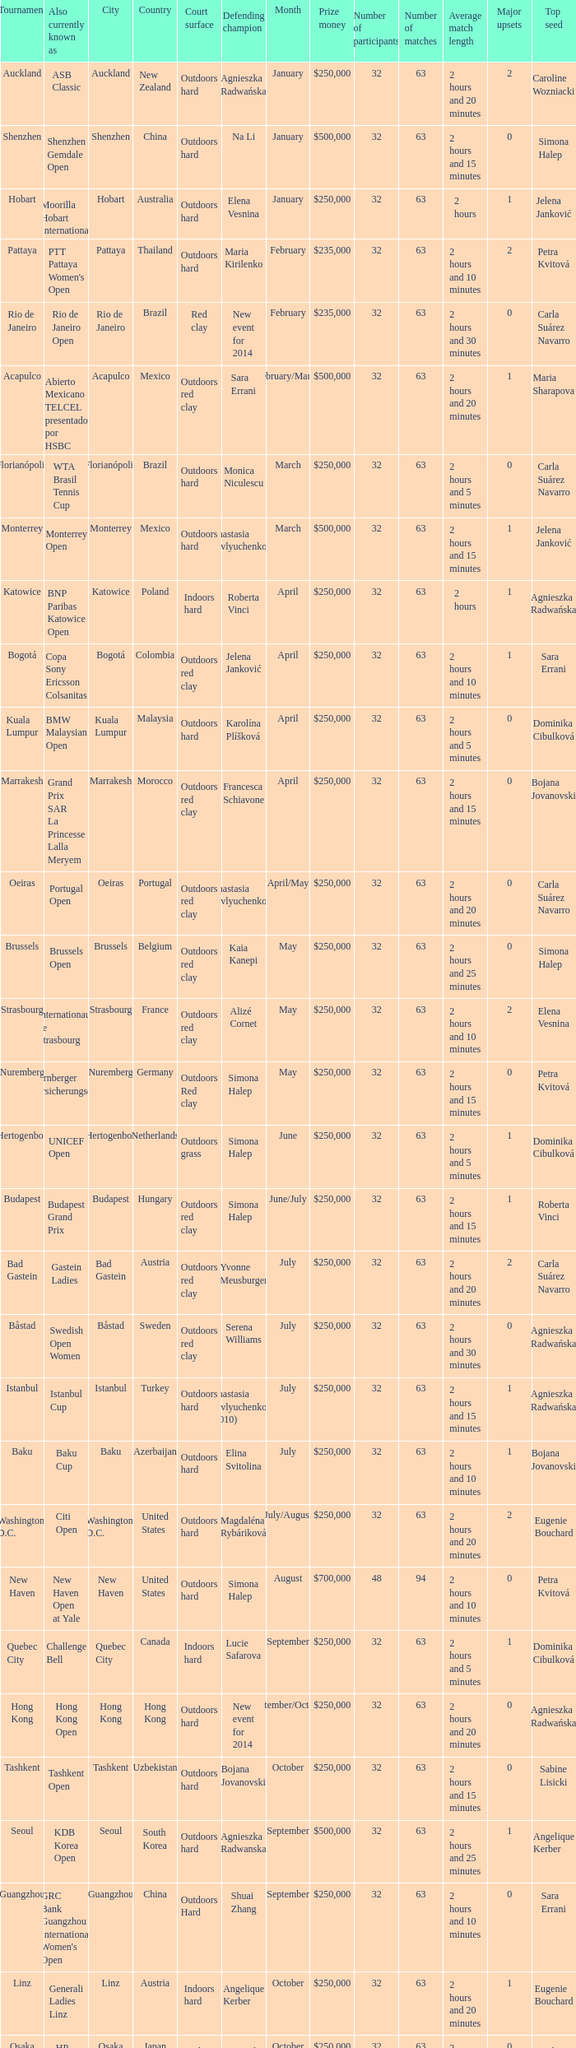How many tournaments are also currently known as the hp open? 1.0. 